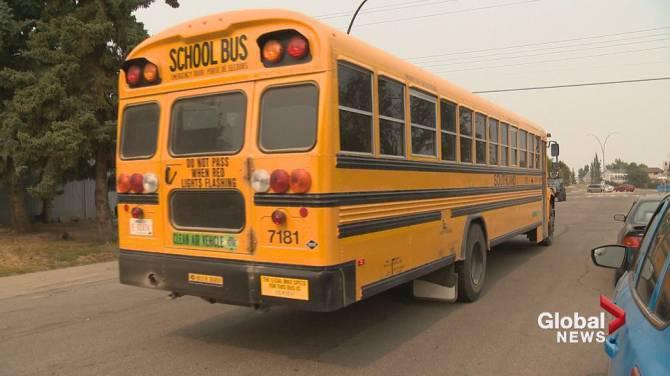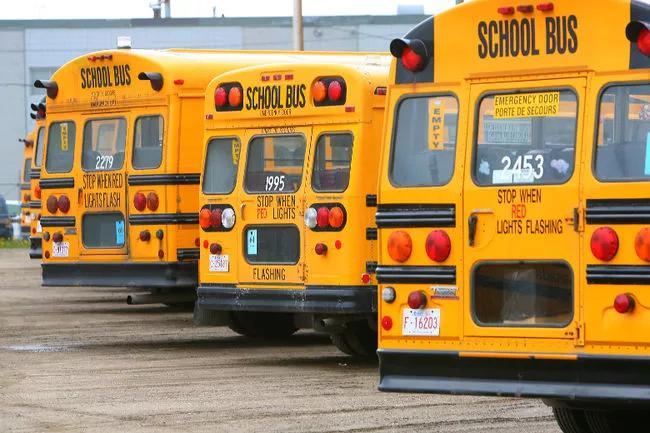The first image is the image on the left, the second image is the image on the right. For the images shown, is this caption "One of the images shows a school bus that has had an accident." true? Answer yes or no. No. The first image is the image on the left, the second image is the image on the right. Examine the images to the left and right. Is the description "There are two buses going in opposite directions." accurate? Answer yes or no. No. 